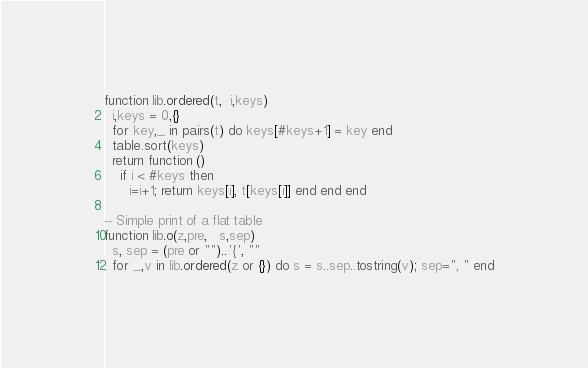<code> <loc_0><loc_0><loc_500><loc_500><_Lua_>function lib.ordered(t,  i,keys)
  i,keys = 0,{}
  for key,_ in pairs(t) do keys[#keys+1] = key end
  table.sort(keys)
  return function ()
    if i < #keys then
      i=i+1; return keys[i], t[keys[i]] end end end 

-- Simple print of a flat table
function lib.o(z,pre,   s,sep) 
  s, sep = (pre or "")..'{', ""
  for _,v in lib.ordered(z or {}) do s = s..sep..tostring(v); sep=", " end</code> 